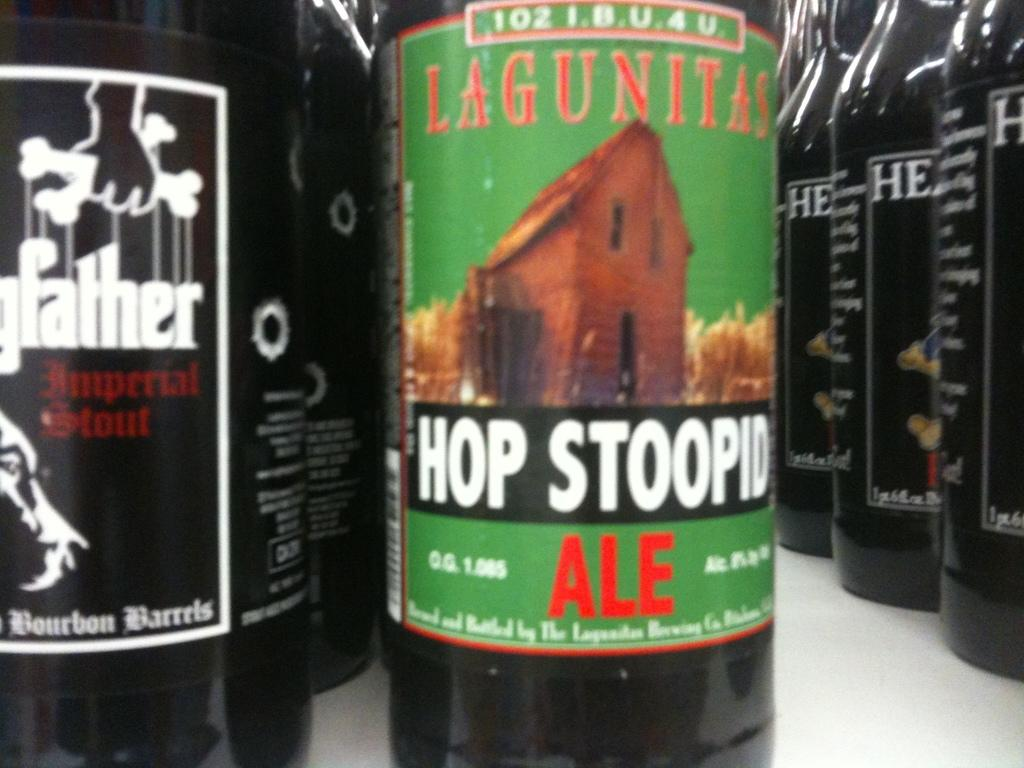<image>
Summarize the visual content of the image. A row of beer bottles including Lagunitas Hop Stoopid Ale. 